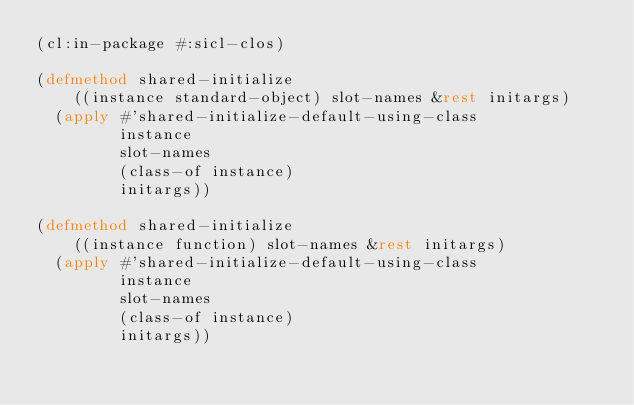Convert code to text. <code><loc_0><loc_0><loc_500><loc_500><_Lisp_>(cl:in-package #:sicl-clos)

(defmethod shared-initialize
    ((instance standard-object) slot-names &rest initargs)
  (apply #'shared-initialize-default-using-class
         instance
         slot-names
         (class-of instance)
         initargs))

(defmethod shared-initialize
    ((instance function) slot-names &rest initargs)
  (apply #'shared-initialize-default-using-class
         instance
         slot-names
         (class-of instance)
         initargs))
</code> 